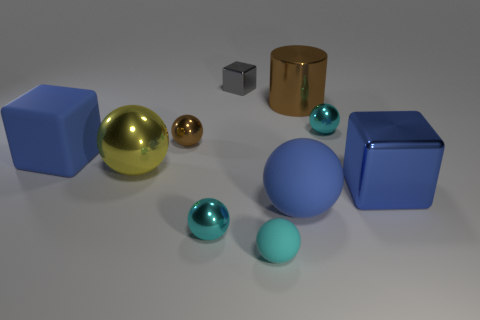Are there any other things that are the same shape as the blue shiny object?
Your response must be concise. Yes. Are there more gray metallic cubes behind the big blue sphere than big gray cubes?
Offer a terse response. Yes. There is a big brown thing in front of the small cube; how many large metal things are to the right of it?
Give a very brief answer. 1. There is a cyan metal object behind the large block on the left side of the tiny cyan shiny thing to the right of the big blue rubber ball; what is its shape?
Ensure brevity in your answer.  Sphere. What size is the yellow metal thing?
Make the answer very short. Large. Are there any tiny brown balls that have the same material as the large blue ball?
Your answer should be very brief. No. There is a cyan matte thing that is the same shape as the small brown shiny object; what size is it?
Ensure brevity in your answer.  Small. Are there the same number of large brown metallic objects that are to the left of the large cylinder and tiny cyan metal balls?
Your response must be concise. No. Do the large object that is on the left side of the yellow metallic ball and the gray object have the same shape?
Offer a terse response. Yes. What shape is the large yellow thing?
Your response must be concise. Sphere. 